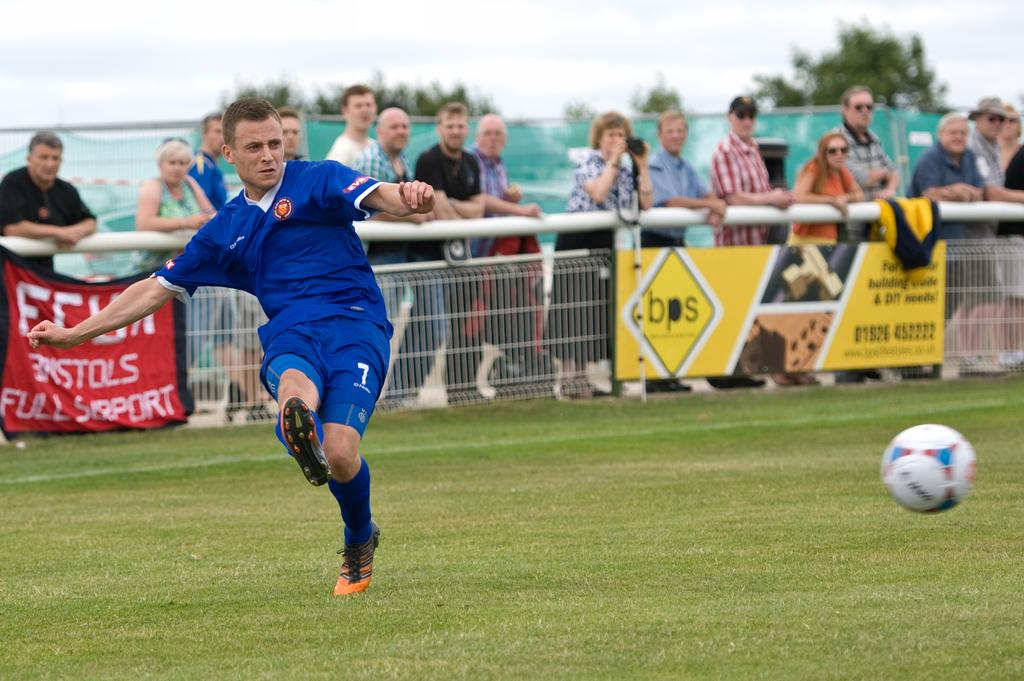<image>
Provide a brief description of the given image. A group of people watch an athlete from behind a fence that is displaying banners such as one advertising full support. 